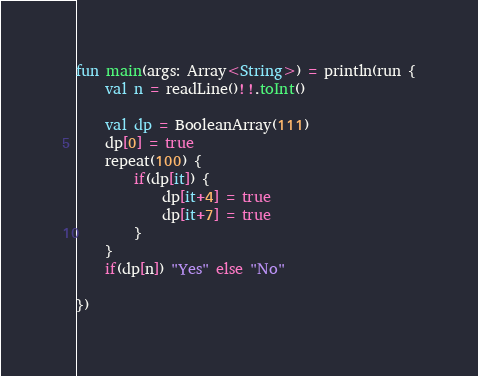Convert code to text. <code><loc_0><loc_0><loc_500><loc_500><_Kotlin_>fun main(args: Array<String>) = println(run {
    val n = readLine()!!.toInt()

    val dp = BooleanArray(111)
    dp[0] = true
    repeat(100) {
        if(dp[it]) {
            dp[it+4] = true
            dp[it+7] = true
        }
    }
    if(dp[n]) "Yes" else "No"

})
</code> 